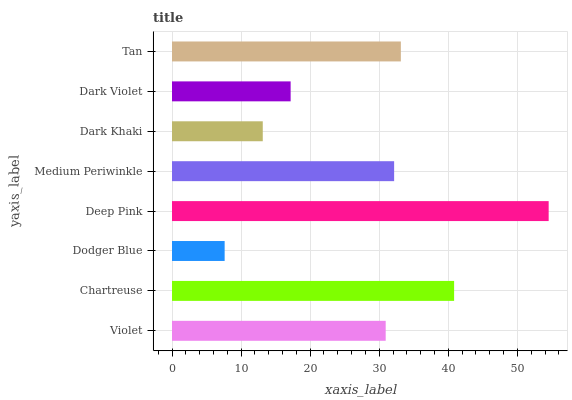Is Dodger Blue the minimum?
Answer yes or no. Yes. Is Deep Pink the maximum?
Answer yes or no. Yes. Is Chartreuse the minimum?
Answer yes or no. No. Is Chartreuse the maximum?
Answer yes or no. No. Is Chartreuse greater than Violet?
Answer yes or no. Yes. Is Violet less than Chartreuse?
Answer yes or no. Yes. Is Violet greater than Chartreuse?
Answer yes or no. No. Is Chartreuse less than Violet?
Answer yes or no. No. Is Medium Periwinkle the high median?
Answer yes or no. Yes. Is Violet the low median?
Answer yes or no. Yes. Is Violet the high median?
Answer yes or no. No. Is Dodger Blue the low median?
Answer yes or no. No. 